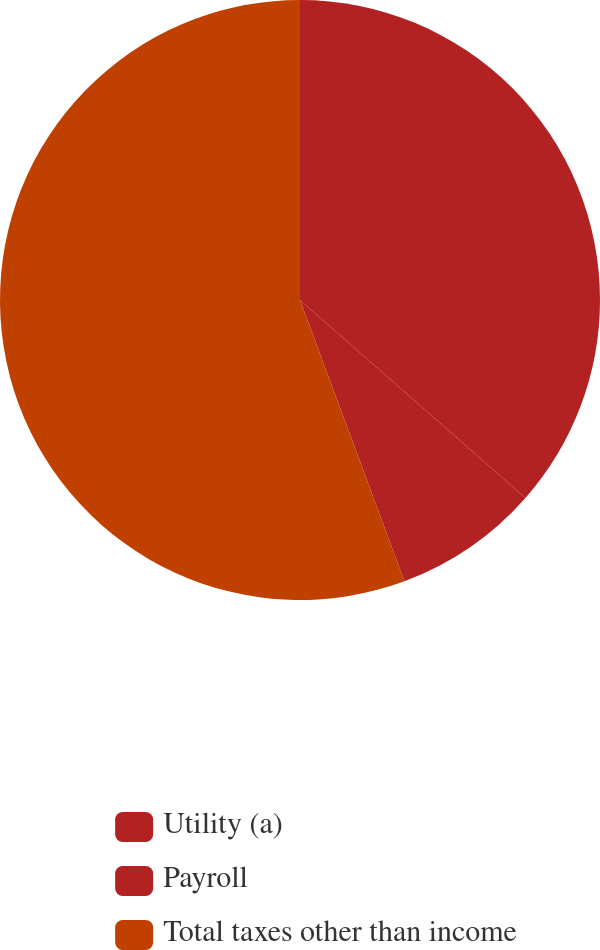Convert chart. <chart><loc_0><loc_0><loc_500><loc_500><pie_chart><fcel>Utility (a)<fcel>Payroll<fcel>Total taxes other than income<nl><fcel>36.47%<fcel>7.87%<fcel>55.66%<nl></chart> 